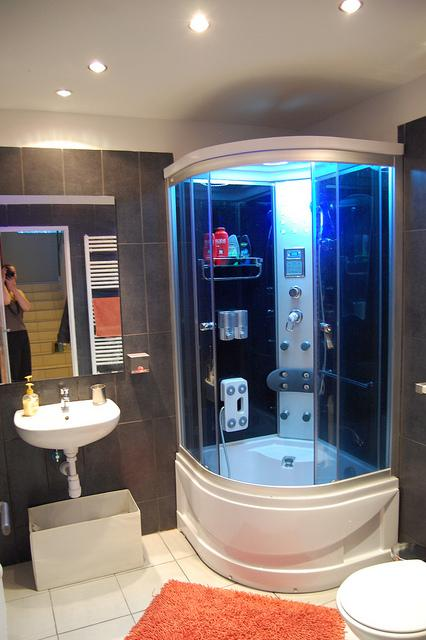What might a person do inside the blue lit area?

Choices:
A) shower
B) text
C) cook
D) rest shower 